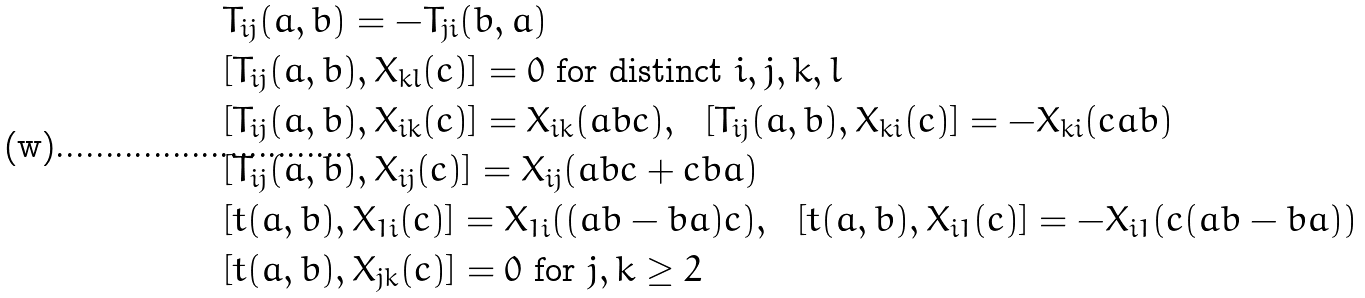<formula> <loc_0><loc_0><loc_500><loc_500>& T _ { i j } ( a , b ) = - T _ { j i } ( b , a ) \\ & [ T _ { i j } ( a , b ) , X _ { k l } ( c ) ] = 0 \text { for distinct } i , j , k , l \\ & [ T _ { i j } ( a , b ) , X _ { i k } ( c ) ] = X _ { i k } ( a b c ) , \ \ [ T _ { i j } ( a , b ) , X _ { k i } ( c ) ] = - X _ { k i } ( c a b ) \\ & [ T _ { i j } ( a , b ) , X _ { i j } ( c ) ] = X _ { i j } ( a b c + c b a ) \\ & [ t ( a , b ) , X _ { 1 i } ( c ) ] = X _ { 1 i } ( ( a b - b a ) c ) , \ \ [ t ( a , b ) , X _ { i 1 } ( c ) ] = - X _ { i 1 } ( c ( a b - b a ) ) \\ & [ t ( a , b ) , X _ { j k } ( c ) ] = 0 \text { for } j , k \geq 2</formula> 